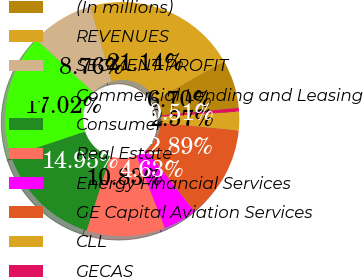Convert chart to OTSL. <chart><loc_0><loc_0><loc_500><loc_500><pie_chart><fcel>(In millions)<fcel>REVENUES<fcel>SEGMENT PROFIT<fcel>Commercial Lending and Leasing<fcel>Consumer<fcel>Real Estate<fcel>Energy Financial Services<fcel>GE Capital Aviation Services<fcel>CLL<fcel>GECAS<nl><fcel>6.7%<fcel>21.14%<fcel>8.76%<fcel>17.02%<fcel>14.95%<fcel>10.83%<fcel>4.63%<fcel>12.89%<fcel>2.57%<fcel>0.51%<nl></chart> 